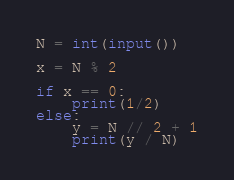<code> <loc_0><loc_0><loc_500><loc_500><_Python_>N = int(input())

x = N % 2

if x == 0:
    print(1/2)
else:
    y = N // 2 + 1
    print(y / N)
</code> 